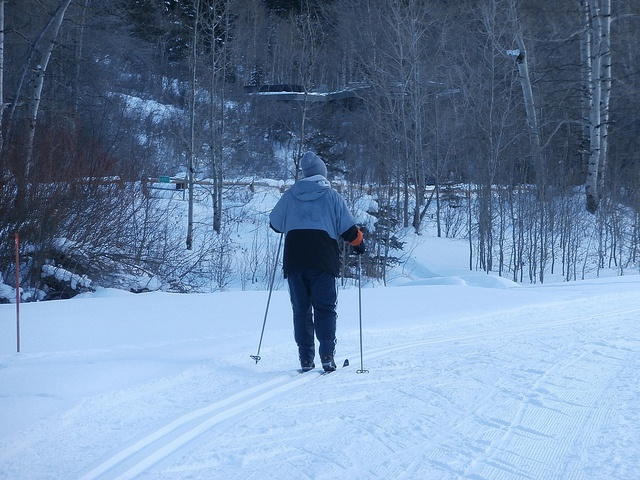Describe the objects in this image and their specific colors. I can see people in navy, black, blue, and gray tones and skis in navy, gray, darkblue, and lightblue tones in this image. 